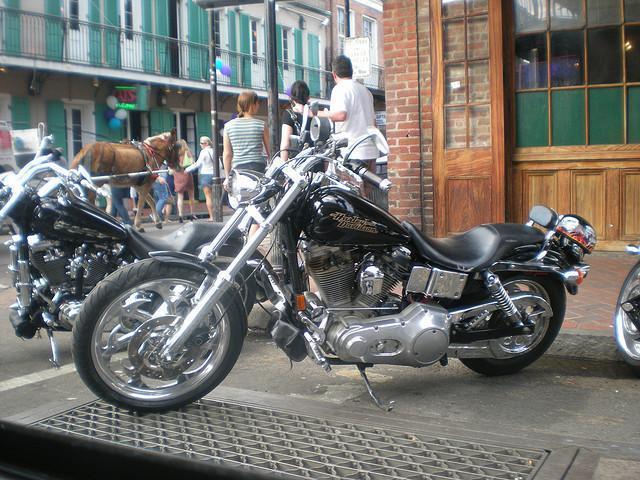What is this type of motorcycle known as?
From the following four choices, select the correct answer to address the question.
Options: Minibike, dirt bike, scooter, cruiser. Cruiser. 